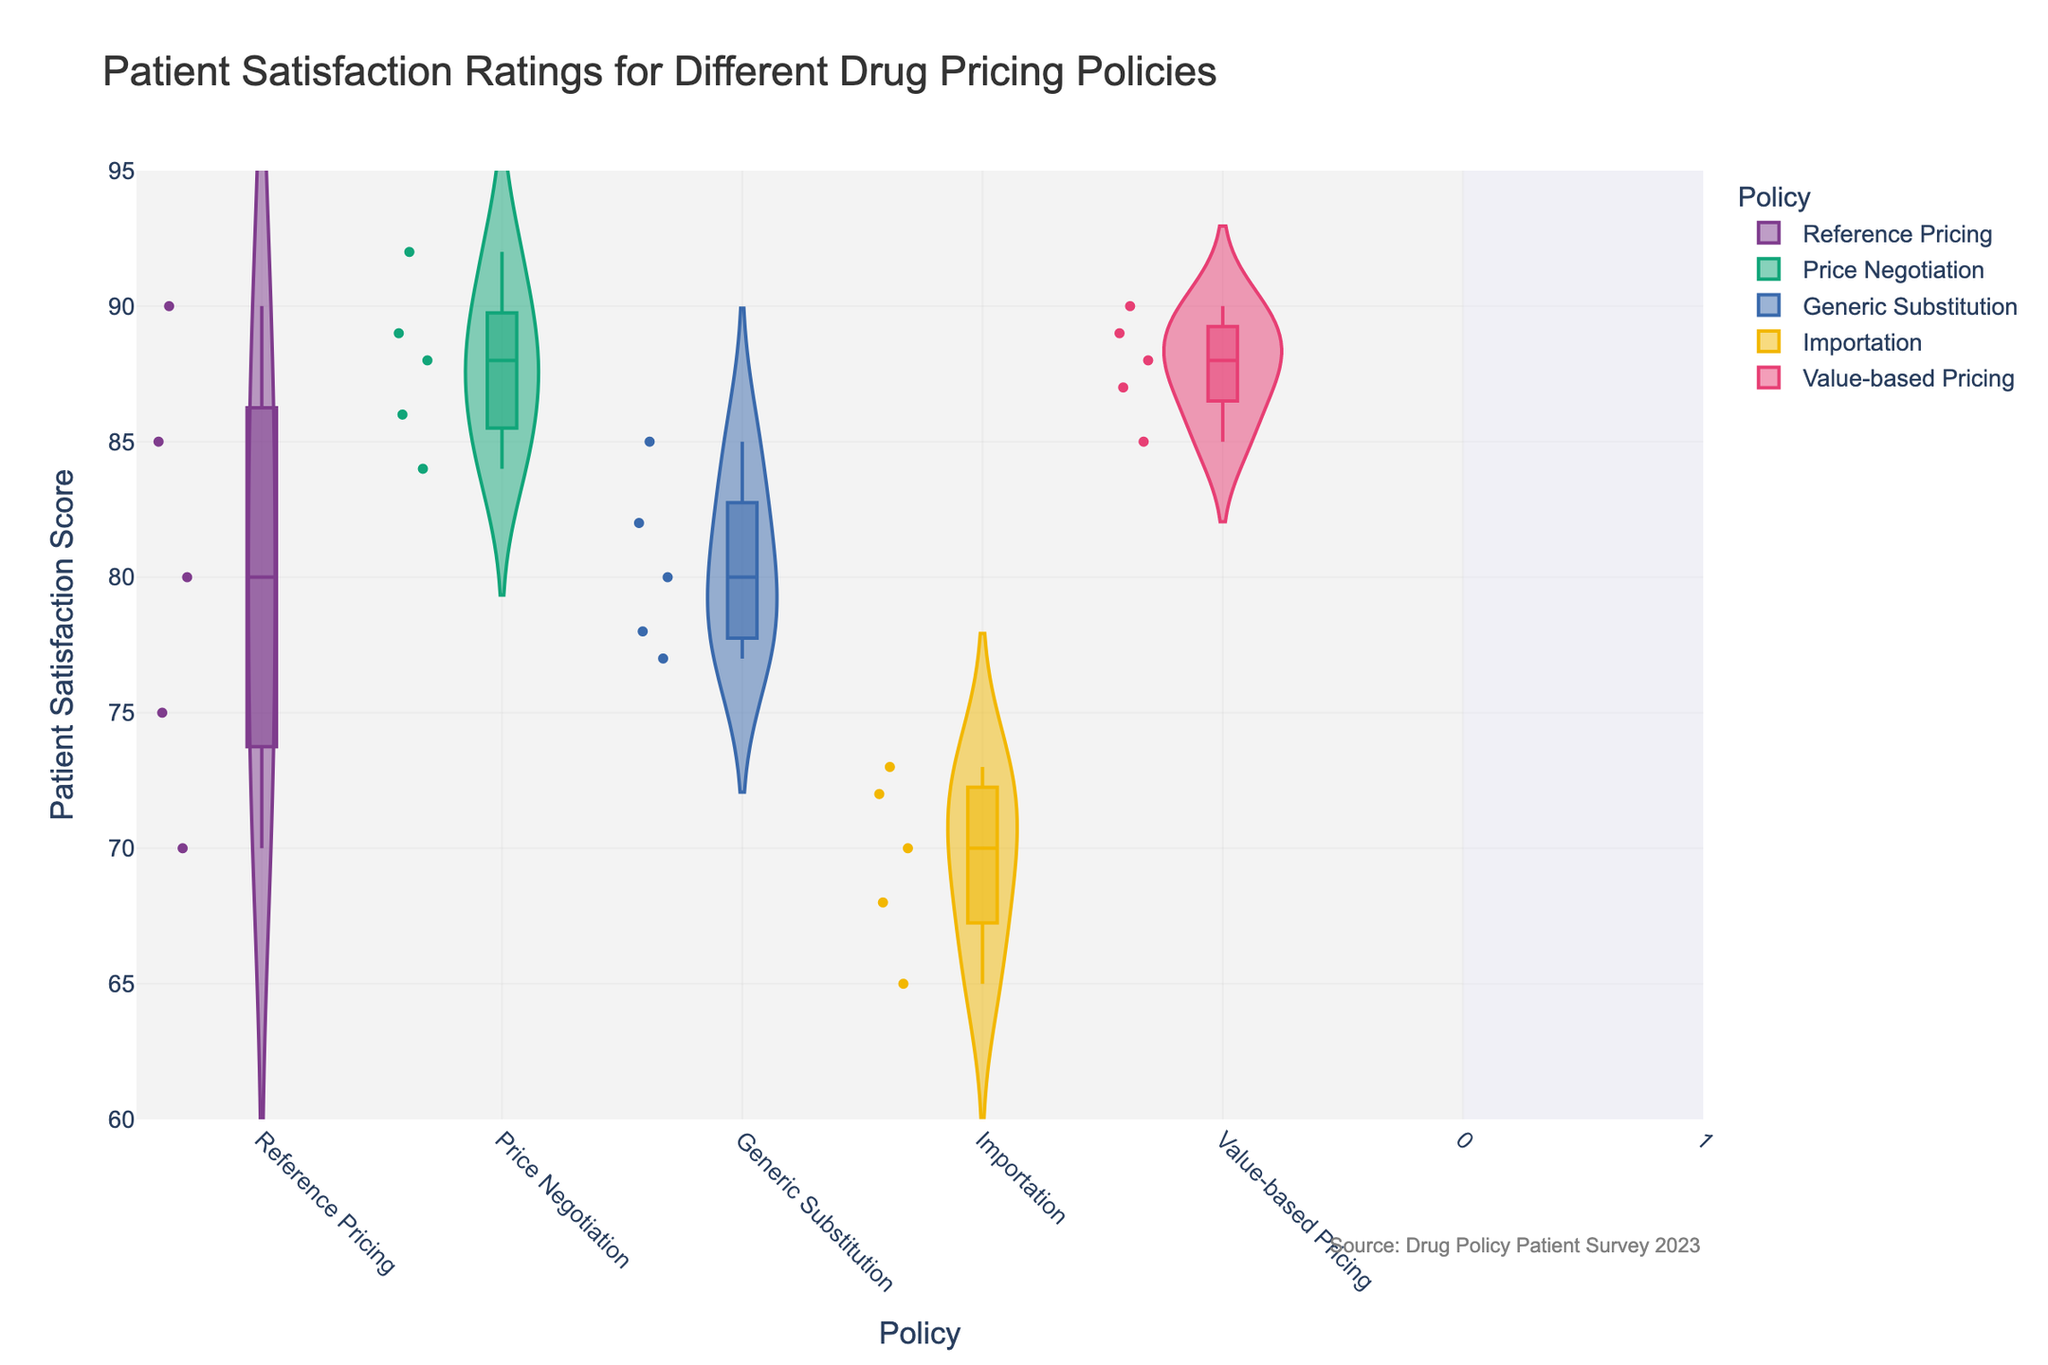What is the title of the figure? The title of the figure can be found at the top of the chart, which summarizes what the visual represents. In this case, it is clearly provided in the figure.
Answer: Patient Satisfaction Ratings for Different Drug Pricing Policies Which policy has the highest median patient satisfaction score? The figure includes box plots within the violin plots. The line inside each violin plot represents the median value. By examining these lines, you can identify which policy has the highest median.
Answer: Value-based Pricing How many data points are there for the "Generic Substitution" policy? Each individual data point is represented as dots within the violin plot for each policy. By counting the dots in the "Generic Substitution" violin, you can determine the number of data points.
Answer: 5 What is the range of patient satisfaction scores for the "Importation" policy? The range can be identified by looking at the minimum and maximum values of the violin plot for the "Importation" policy. This represents the spread from the lowest to the highest patient satisfaction score.
Answer: 65-73 Which policy has the widest distribution of patient satisfaction scores? The width of the distribution can be assessed by examining how spread out the violin plot is. The policy with the largest range from minimum to maximum will have the widest distribution.
Answer: Reference Pricing What is the average patient satisfaction score for the "Price Negotiation" policy? To find the average, sum all the patient satisfaction scores for the "Price Negotiation" policy and divide by the number of data points: (89 + 92 + 88 + 84 + 86) / 5.
Answer: 87.8 Which policy shows the least variation in patient satisfaction scores? The variation in scores can be evaluated by looking at the tightness of the violin plot. The plot with the narrowest range indicates the least variation.
Answer: Value-based Pricing Are there any outliers in the "Reference Pricing" policy? Outliers are often represented by individual points that fall well outside the main body of the violin plot or box plot. By inspecting the visual representation, you can check for any such outliers.
Answer: No How do the median satisfaction scores compare between "Generic Substitution" and "Importation"? To compare the median scores, look at the horizontal lines inside the violin plots for both policies and determine which one is higher or if they are similar.
Answer: Generic Substitution is higher Which policies have patient satisfaction scores ranging over 90? To determine which policies have scores over 90, look at the upper end of the violin plots and identify any that extend above the 90 mark.
Answer: Price Negotiation, Value-based Pricing 